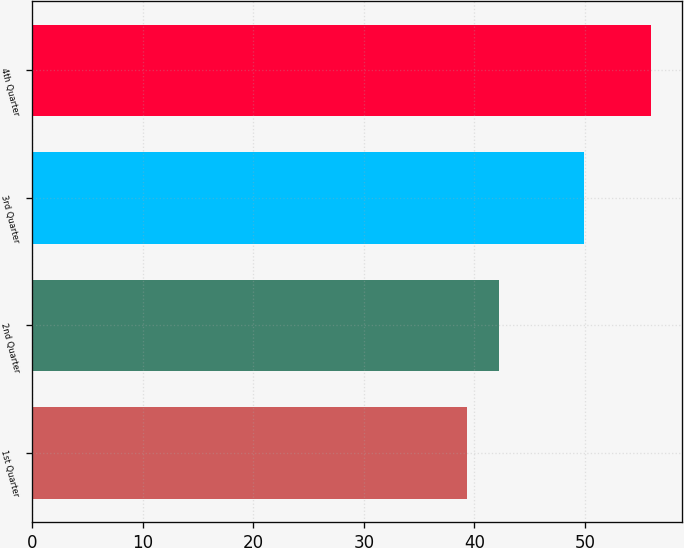Convert chart to OTSL. <chart><loc_0><loc_0><loc_500><loc_500><bar_chart><fcel>1st Quarter<fcel>2nd Quarter<fcel>3rd Quarter<fcel>4th Quarter<nl><fcel>39.31<fcel>42.25<fcel>49.89<fcel>55.95<nl></chart> 